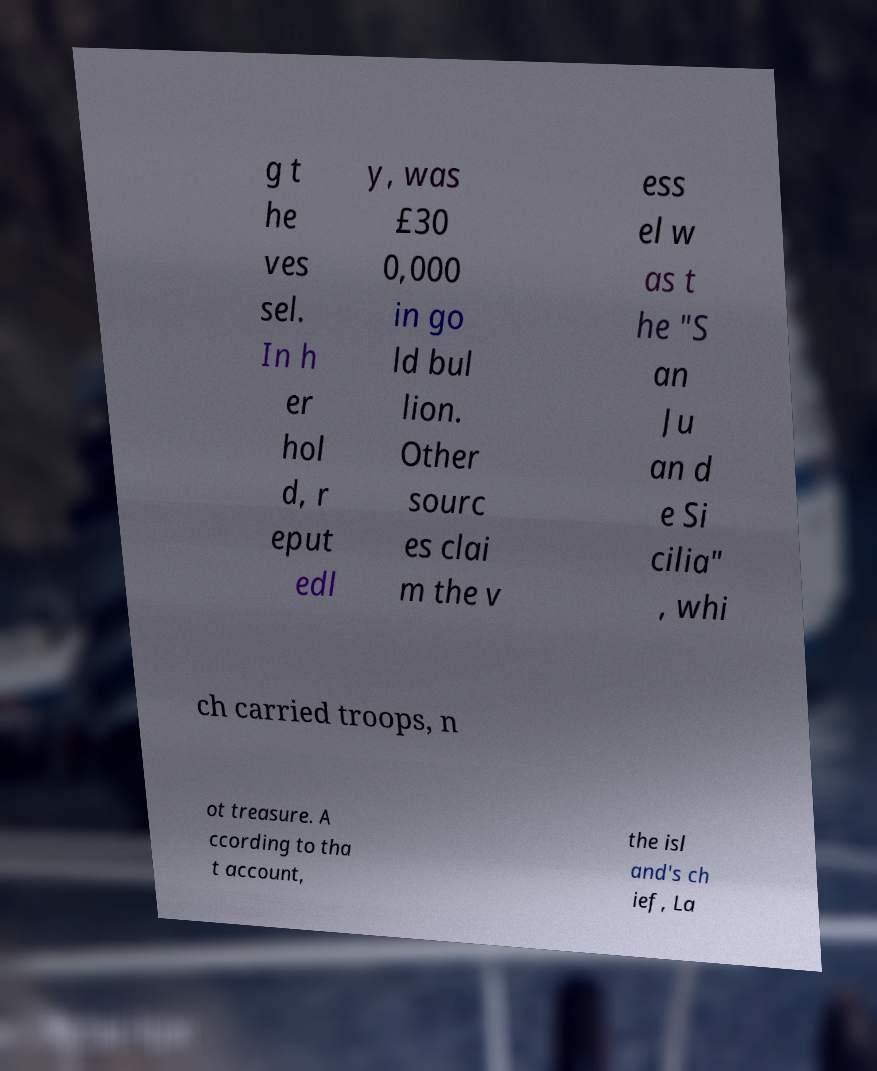Can you accurately transcribe the text from the provided image for me? g t he ves sel. In h er hol d, r eput edl y, was £30 0,000 in go ld bul lion. Other sourc es clai m the v ess el w as t he "S an Ju an d e Si cilia" , whi ch carried troops, n ot treasure. A ccording to tha t account, the isl and's ch ief, La 